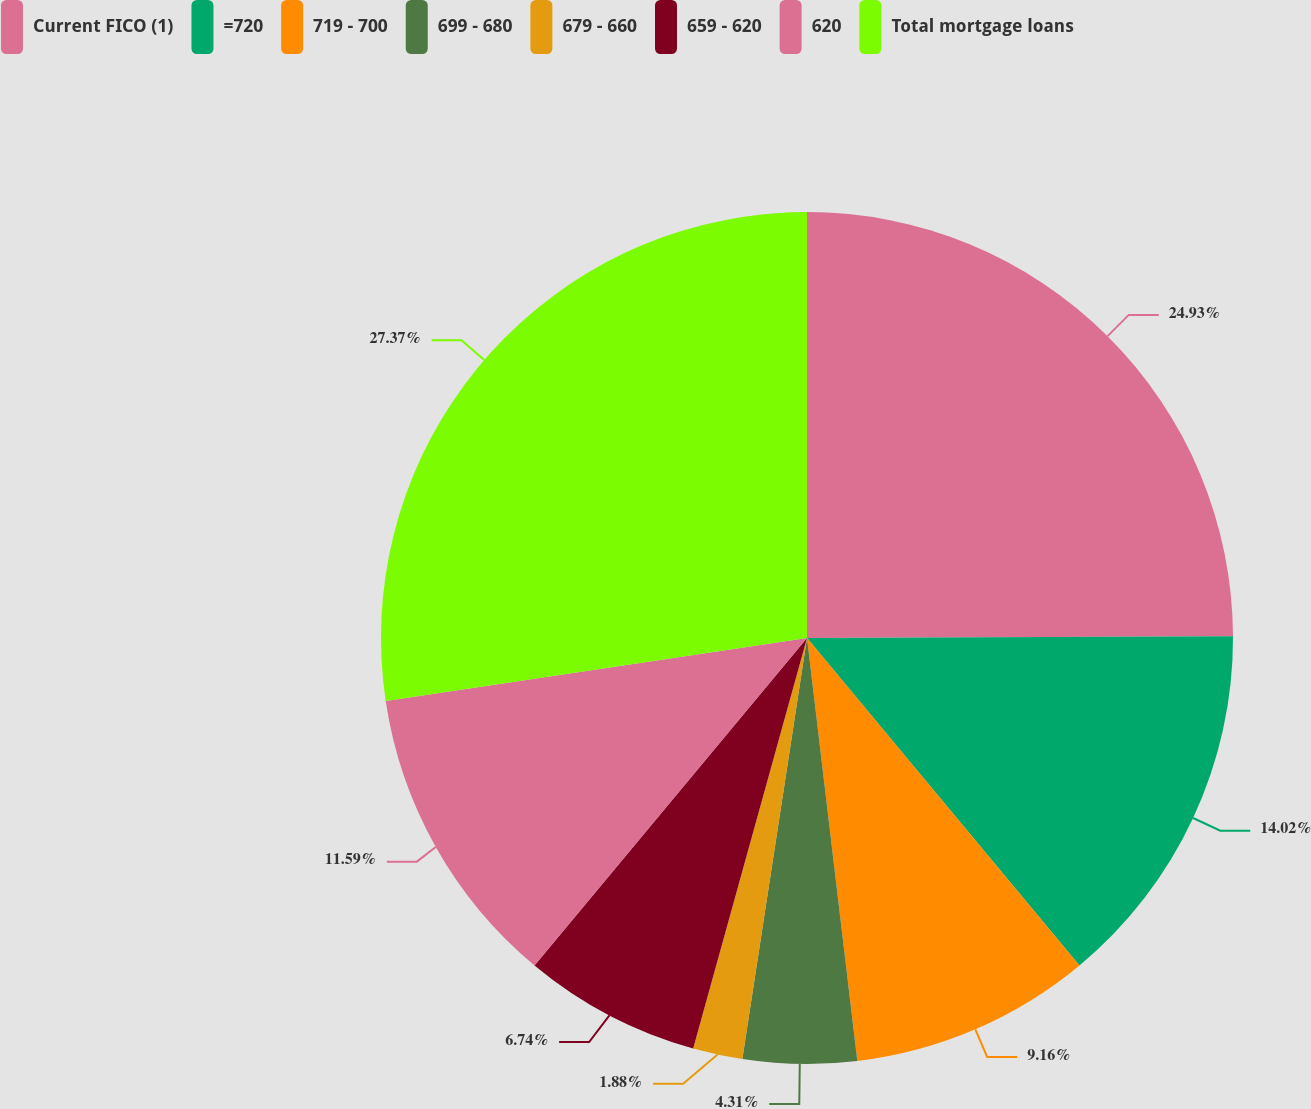<chart> <loc_0><loc_0><loc_500><loc_500><pie_chart><fcel>Current FICO (1)<fcel>=720<fcel>719 - 700<fcel>699 - 680<fcel>679 - 660<fcel>659 - 620<fcel>620<fcel>Total mortgage loans<nl><fcel>24.93%<fcel>14.02%<fcel>9.16%<fcel>4.31%<fcel>1.88%<fcel>6.74%<fcel>11.59%<fcel>27.36%<nl></chart> 